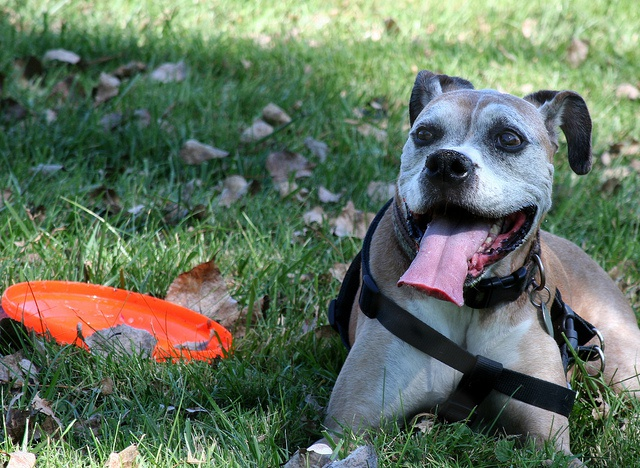Describe the objects in this image and their specific colors. I can see dog in lightgreen, black, gray, and darkgray tones and frisbee in lightgreen, red, and salmon tones in this image. 